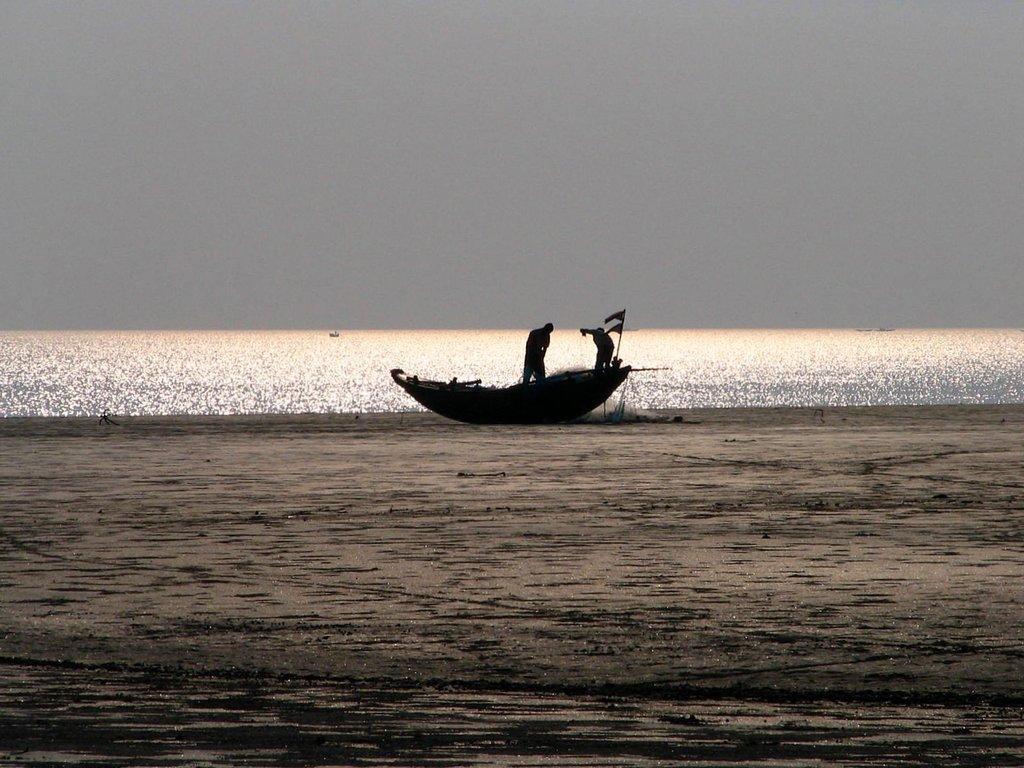In one or two sentences, can you explain what this image depicts? In the picture we can see two persons standing in the boat and we can see flags. Here we can see the sand, the water and the plain sky in the background. 